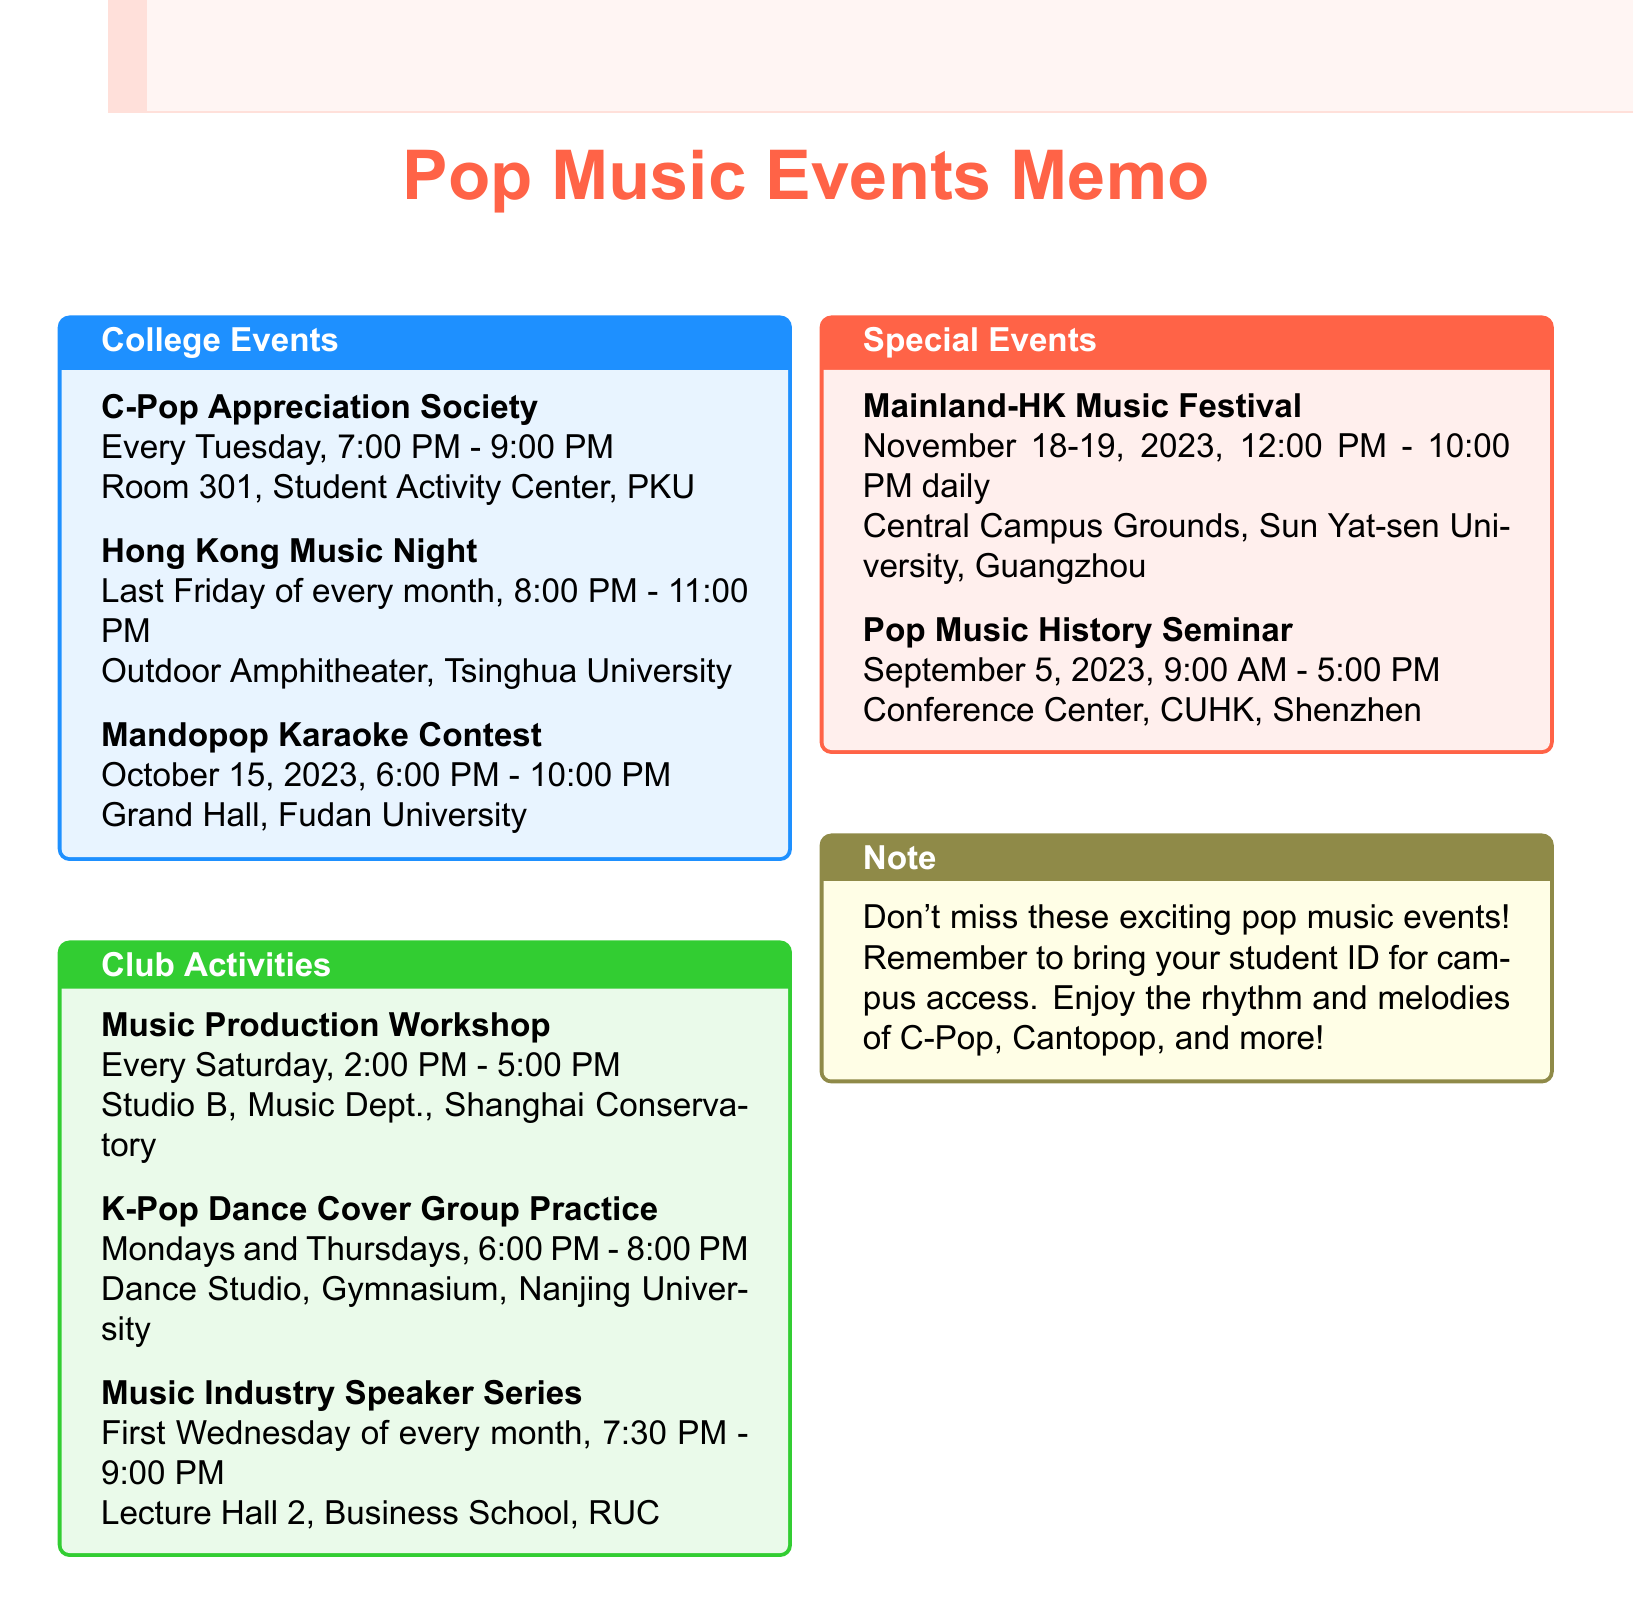What day and time does the C-Pop Appreciation Society meet? The C-Pop Appreciation Society meets every Tuesday from 7:00 PM to 9:00 PM.
Answer: Every Tuesday, 7:00 PM - 9:00 PM Where is the Hong Kong Music Night held? The Hong Kong Music Night is held at the Outdoor Amphitheater, Tsinghua University.
Answer: Outdoor Amphitheater, Tsinghua University What month is the Mandopop Karaoke Contest scheduled for? The Mandopop Karaoke Contest is scheduled for October.
Answer: October When does the Music Industry Speaker Series take place? The Music Industry Speaker Series takes place on the first Wednesday of every month.
Answer: First Wednesday of every month How often are the K-Pop Dance Cover Group practices held? The K-Pop Dance Cover Group practices are held on Mondays and Thursdays.
Answer: Mondays and Thursdays What are the dates for the Mainland-HK Music Festival? The Mainland-HK Music Festival is on November 18-19, 2023.
Answer: November 18-19, 2023 What is the main focus of the Music Production Workshop? The main focus of the Music Production Workshop is to create and produce pop music.
Answer: Create and produce pop music What time does the Pop Music History Seminar start? The Pop Music History Seminar starts at 9:00 AM.
Answer: 9:00 AM What should attendees remember to bring for campus access? Attendees should remember to bring their student ID for campus access.
Answer: Student ID 